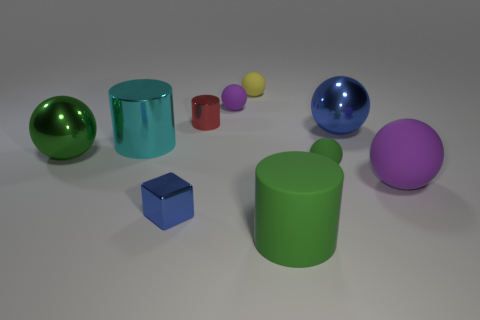Subtract all red cylinders. How many cylinders are left? 2 Subtract all cyan cylinders. How many purple spheres are left? 2 Subtract all blue balls. How many balls are left? 5 Subtract all cylinders. How many objects are left? 7 Subtract 2 cylinders. How many cylinders are left? 1 Subtract 0 yellow cubes. How many objects are left? 10 Subtract all cyan balls. Subtract all gray blocks. How many balls are left? 6 Subtract all big cyan rubber cylinders. Subtract all red shiny cylinders. How many objects are left? 9 Add 8 big purple objects. How many big purple objects are left? 9 Add 7 small gray things. How many small gray things exist? 7 